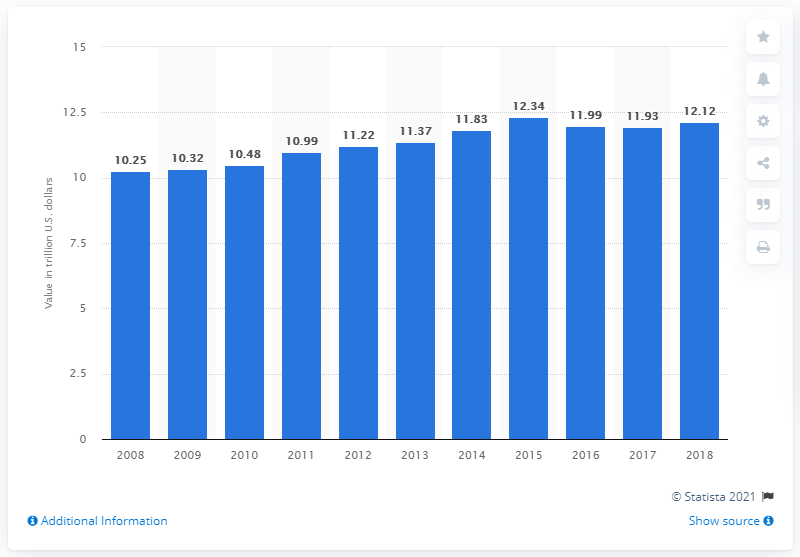Specify some key components in this picture. In 2018, the value of individual life insurance in force was approximately 12.12. 